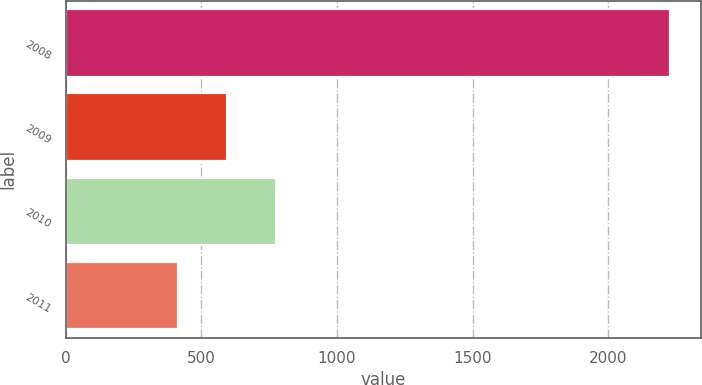Convert chart. <chart><loc_0><loc_0><loc_500><loc_500><bar_chart><fcel>2008<fcel>2009<fcel>2010<fcel>2011<nl><fcel>2229<fcel>594.6<fcel>776.2<fcel>413<nl></chart> 